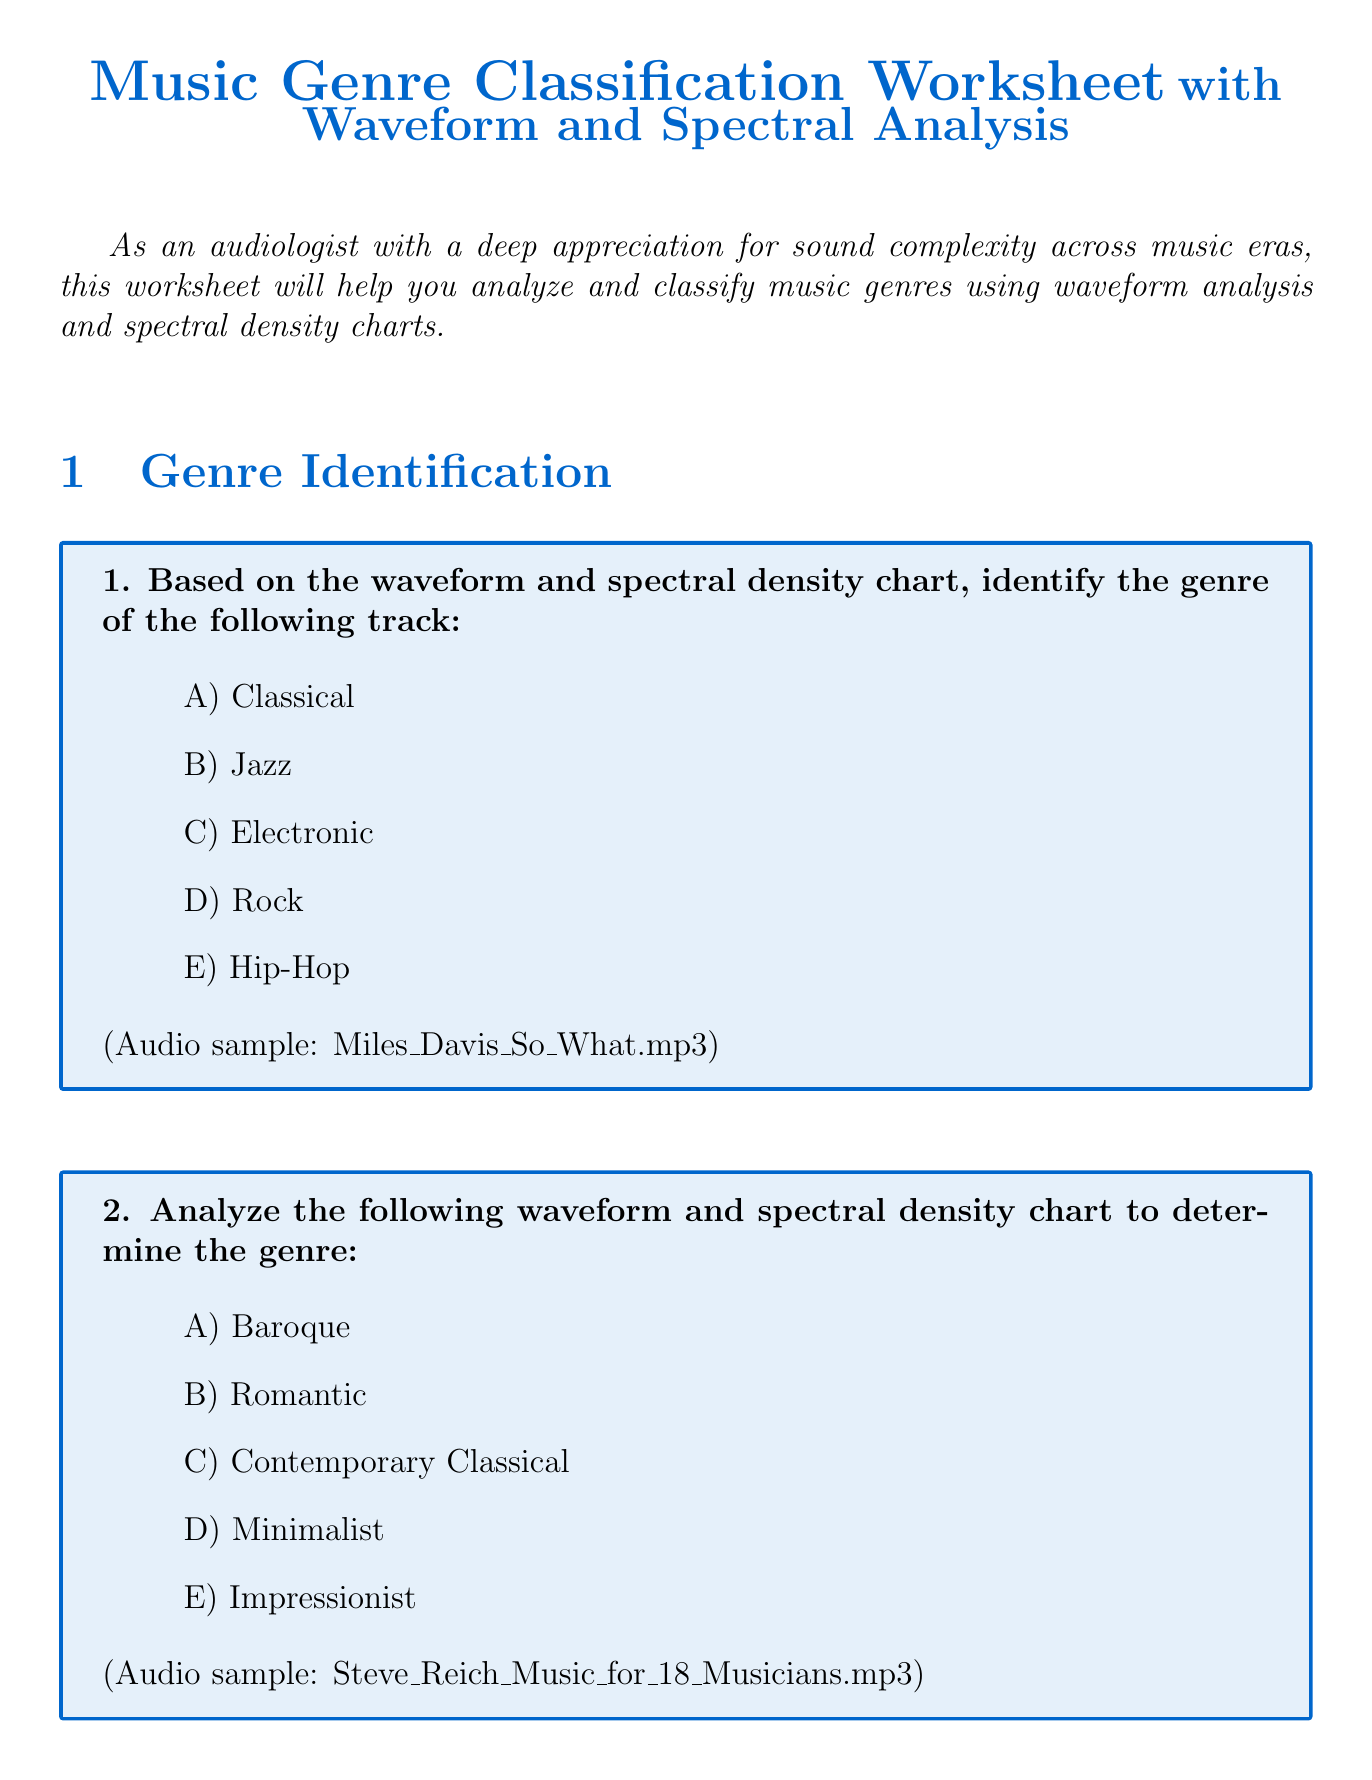what is the title of the worksheet? The title of the worksheet is stated at the beginning of the document.
Answer: Music Genre Classification Worksheet with Waveform and Spectral Analysis which genre is identified for the audio sample "Miles_Davis_So_What.mp3"? The document specifies the correct genre answer associated with the waveform and spectral density chart for this audio sample.
Answer: Jazz what is the first item under Waveform Analysis? The document lists the first question in the Waveform Analysis section.
Answer: Describe the characteristics of the waveform for Beethoven's Symphony No. 5 in C minor, Op. 67 how many tracks are compared in the Cross-Era Comparison section? The document outlines the number of tracks included in the comparison.
Answer: Three which genre corresponds to the waveform with "High amplitude throughout with less dynamic range"? The document includes a matching section that links waveform characteristics to genres.
Answer: Heavy Metal what does the spectrogram for "John Coltrane's 'Giant Steps'" reflect about the genre? The analysis question points to the complexities associated with bebop jazz stated in the document.
Answer: Complexity of bebop jazz is classical orchestral music typically more evenly distributed in frequencies compared to electronic music? The true or false question in the document evaluates this specific statement about classical orchestral music.
Answer: True what is one characteristic to consider when analyzing the waveform for Beethoven's Symphony No. 5? The document lists specific characteristics to focus on for this analysis.
Answer: Amplitude variations what kind of chart is used for genre classification in this worksheet? The introduction mentions the types of charts used for analyzing music genres.
Answer: Spectral density charts 